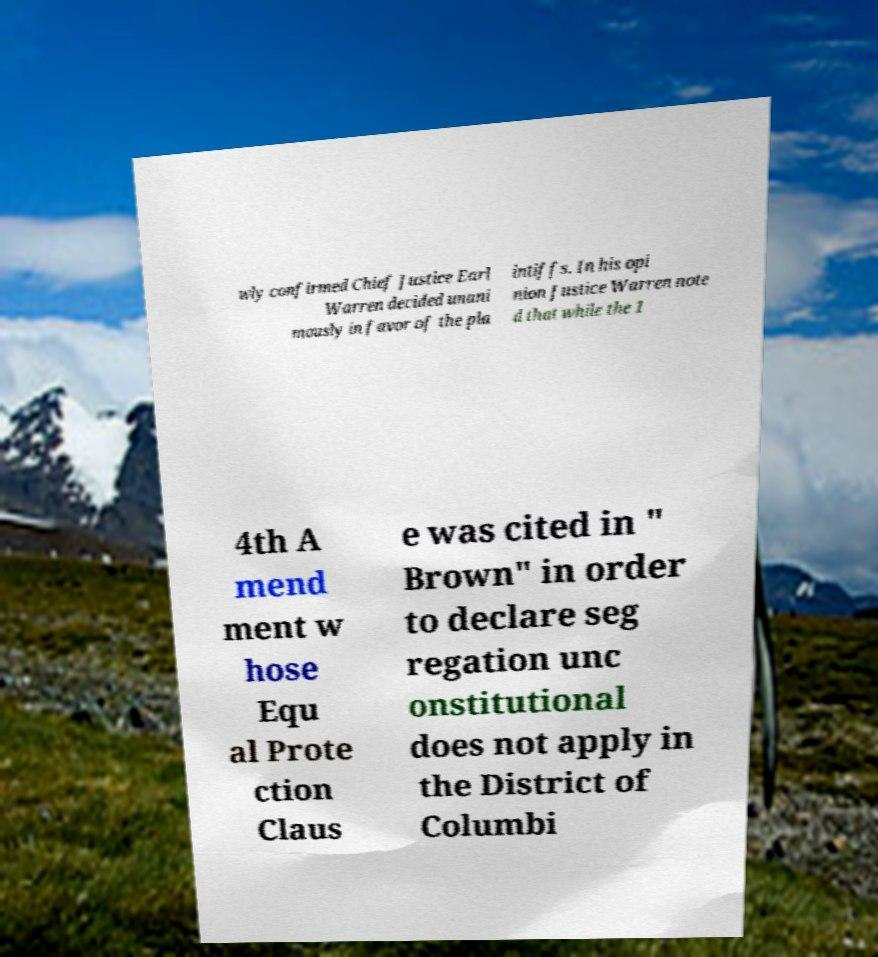Can you accurately transcribe the text from the provided image for me? wly confirmed Chief Justice Earl Warren decided unani mously in favor of the pla intiffs. In his opi nion Justice Warren note d that while the 1 4th A mend ment w hose Equ al Prote ction Claus e was cited in " Brown" in order to declare seg regation unc onstitutional does not apply in the District of Columbi 